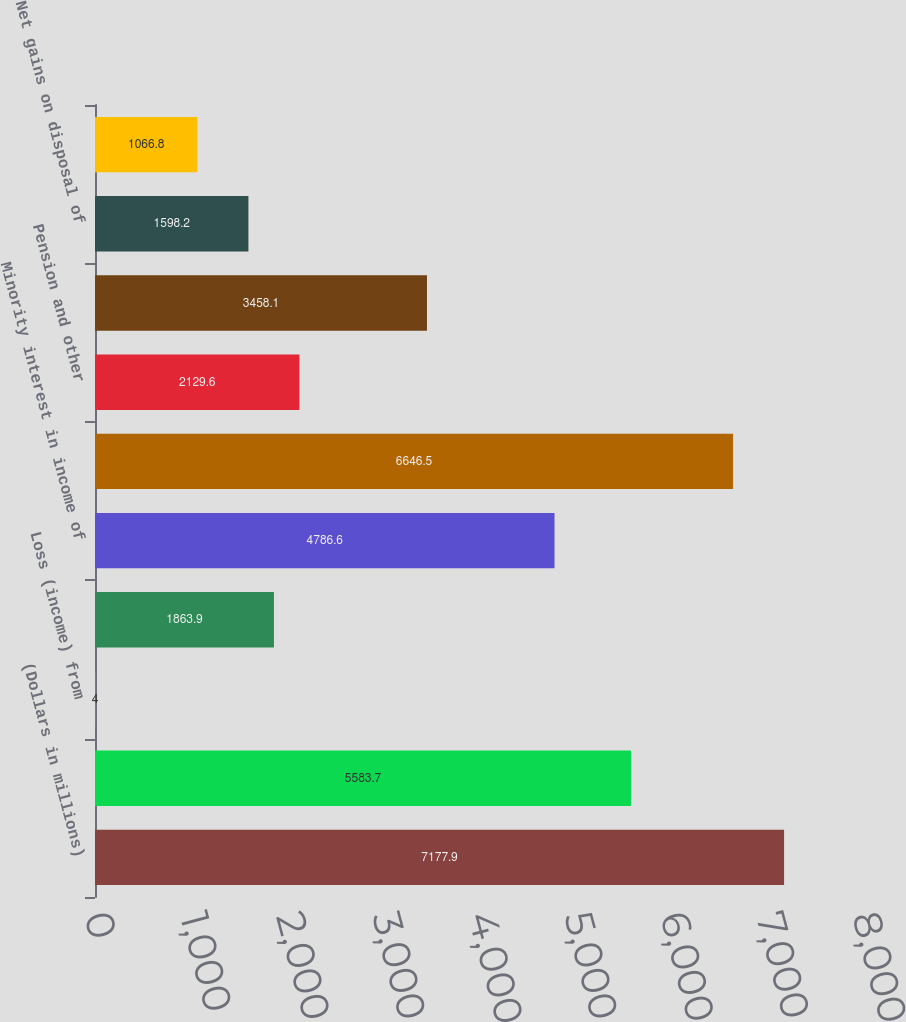Convert chart to OTSL. <chart><loc_0><loc_0><loc_500><loc_500><bar_chart><fcel>(Dollars in millions)<fcel>Net income<fcel>Loss (income) from<fcel>Deferred income taxes<fcel>Minority interest in income of<fcel>Depreciation depletion and<fcel>Pension and other<fcel>Exploratory dry well costs and<fcel>Net gains on disposal of<fcel>Changes in the fair value of<nl><fcel>7177.9<fcel>5583.7<fcel>4<fcel>1863.9<fcel>4786.6<fcel>6646.5<fcel>2129.6<fcel>3458.1<fcel>1598.2<fcel>1066.8<nl></chart> 